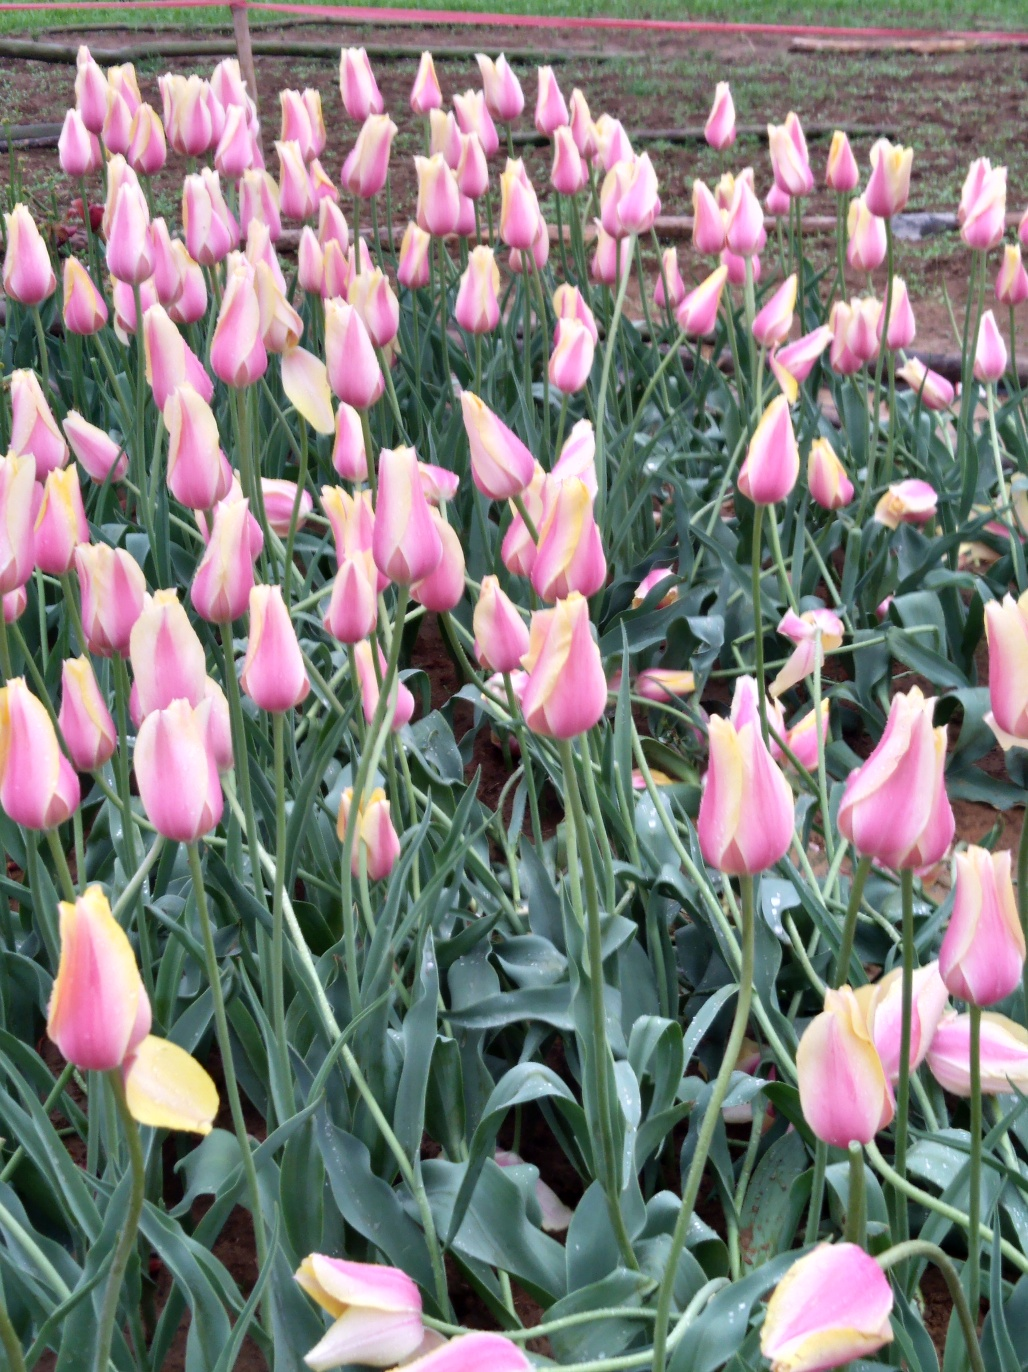Can you tell me what type of flowers are these? These are tulips, known for their distinctive shape and vibrant colors. They're a popular springtime flower and a symbol of Holland, though they are cultivated in many parts of the world. Why are some of them bending or drooping? Tulips may bend or droop for several reasons, including the weight of the flower, growth towards light (phototropism), or insufficient water. In a garden setting, it's common for some stems to bend, especially as the flowers mature or after heavy rain. 